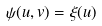<formula> <loc_0><loc_0><loc_500><loc_500>\psi ( u , v ) = \xi ( u )</formula> 